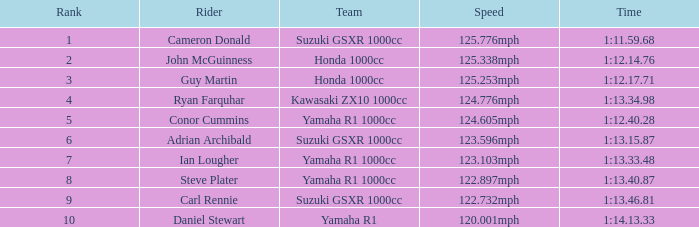What is the rank for the team with a Time of 1:12.40.28? 5.0. 